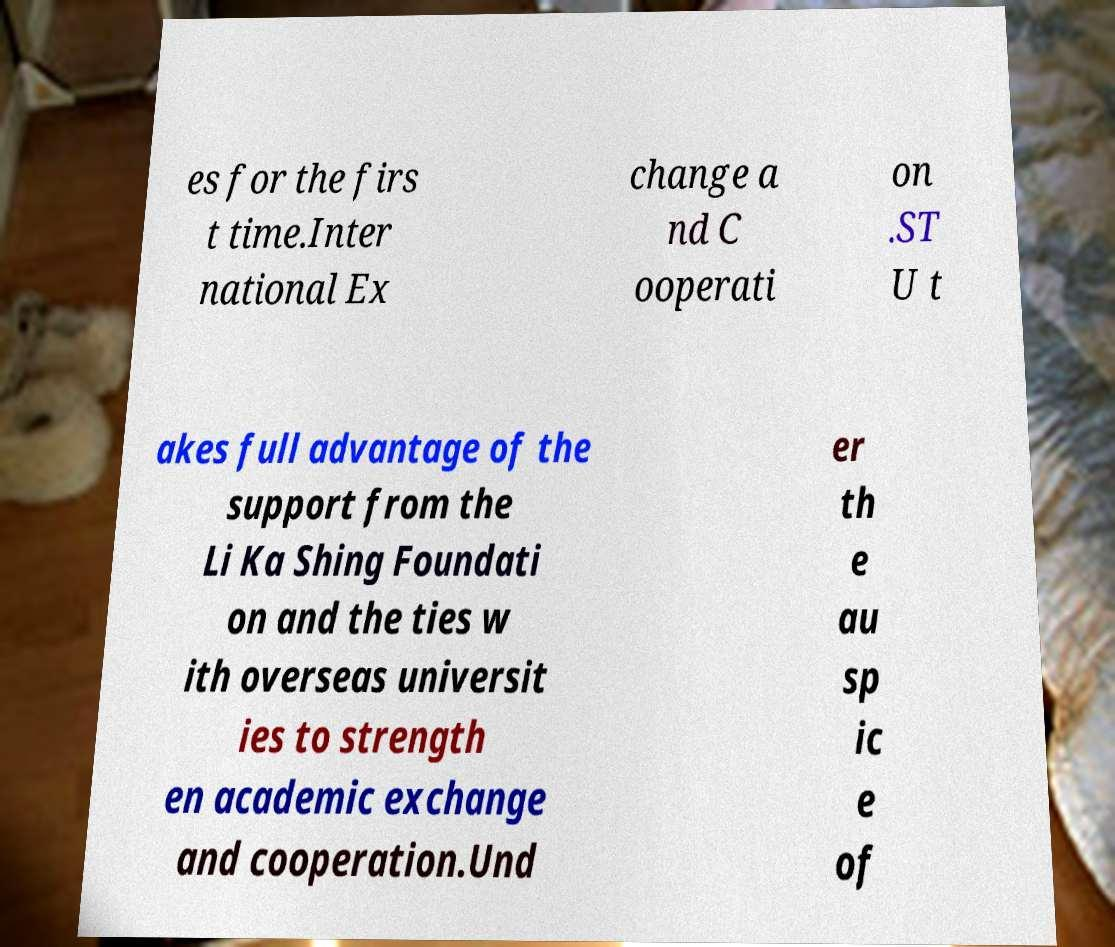For documentation purposes, I need the text within this image transcribed. Could you provide that? es for the firs t time.Inter national Ex change a nd C ooperati on .ST U t akes full advantage of the support from the Li Ka Shing Foundati on and the ties w ith overseas universit ies to strength en academic exchange and cooperation.Und er th e au sp ic e of 